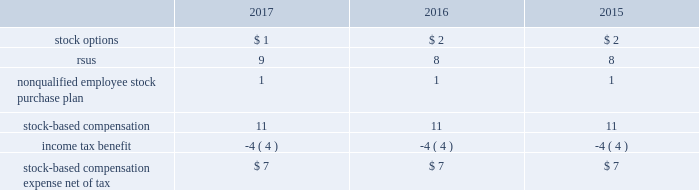On may 12 , 2017 , the company 2019s stockholders approved the american water works company , inc .
2017 omnibus equity compensation plan ( the 201c2017 omnibus plan 201d ) .
A total of 7.2 million shares of common stock may be issued under the 2017 omnibus plan .
As of december 31 , 2017 , 7.2 million shares were available for grant under the 2017 omnibus plan .
The 2017 omnibus plan provides that grants of awards may be in any of the following forms : incentive stock options , nonqualified stock options , stock appreciation rights , stock units , stock awards , other stock-based awards and dividend equivalents , which may be granted only on stock units or other stock-based awards .
Following the approval of the 2017 omnibus plan , no additional awards are to be granted under the 2007 plan .
However , shares will still be issued under the 2007 plan pursuant to the terms of awards previously issued under that plan prior to may 12 , 2017 .
The cost of services received from employees in exchange for the issuance of stock options and restricted stock awards is measured based on the grant date fair value of the awards issued .
The value of stock options and rsus awards at the date of the grant is amortized through expense over the three-year service period .
All awards granted in 2017 , 2016 and 2015 are classified as equity .
The company recognizes compensation expense for stock awards over the vesting period of the award .
The company stratified its grant populations and used historic employee turnover rates to estimate employee forfeitures .
The estimated rate is compared to the actual forfeitures at the end of the reporting period and adjusted as necessary .
The table presents stock-based compensation expense recorded in operation and maintenance expense in the accompanying consolidated statements of operations for the years ended december 31: .
There were no significant stock-based compensation costs capitalized during the years ended december 31 , 2017 , 2016 and 2015 .
The company receives a tax deduction based on the intrinsic value of the award at the exercise date for stock options and the distribution date for rsus .
For each award , throughout the requisite service period , the company recognizes the tax benefits , which have been included in deferred income tax assets , related to compensation costs .
The tax deductions in excess of the benefits recorded throughout the requisite service period are recorded to the consolidated statements of operations and are presented in the financing section of the consolidated statements of cash flows .
Stock options there were no grants of stock options to employees in 2017 .
In 2016 and 2015 , the company granted non-qualified stock options to certain employees under the 2007 plan .
The stock options vest ratably over the three-year service period beginning on january 1 of the year of the grant and have no performance vesting conditions .
Expense is recognized using the straight-line method and is amortized over the requisite service period. .
What was the percent of the tax benefit as a part of the stock based compensation in 2017? 
Rationale: the tax benefit rate as a percent of the stock based compensation expense the division of the tax by the total expense multiplied by 100 .
Computations: (4 / 11)
Answer: 0.36364. 